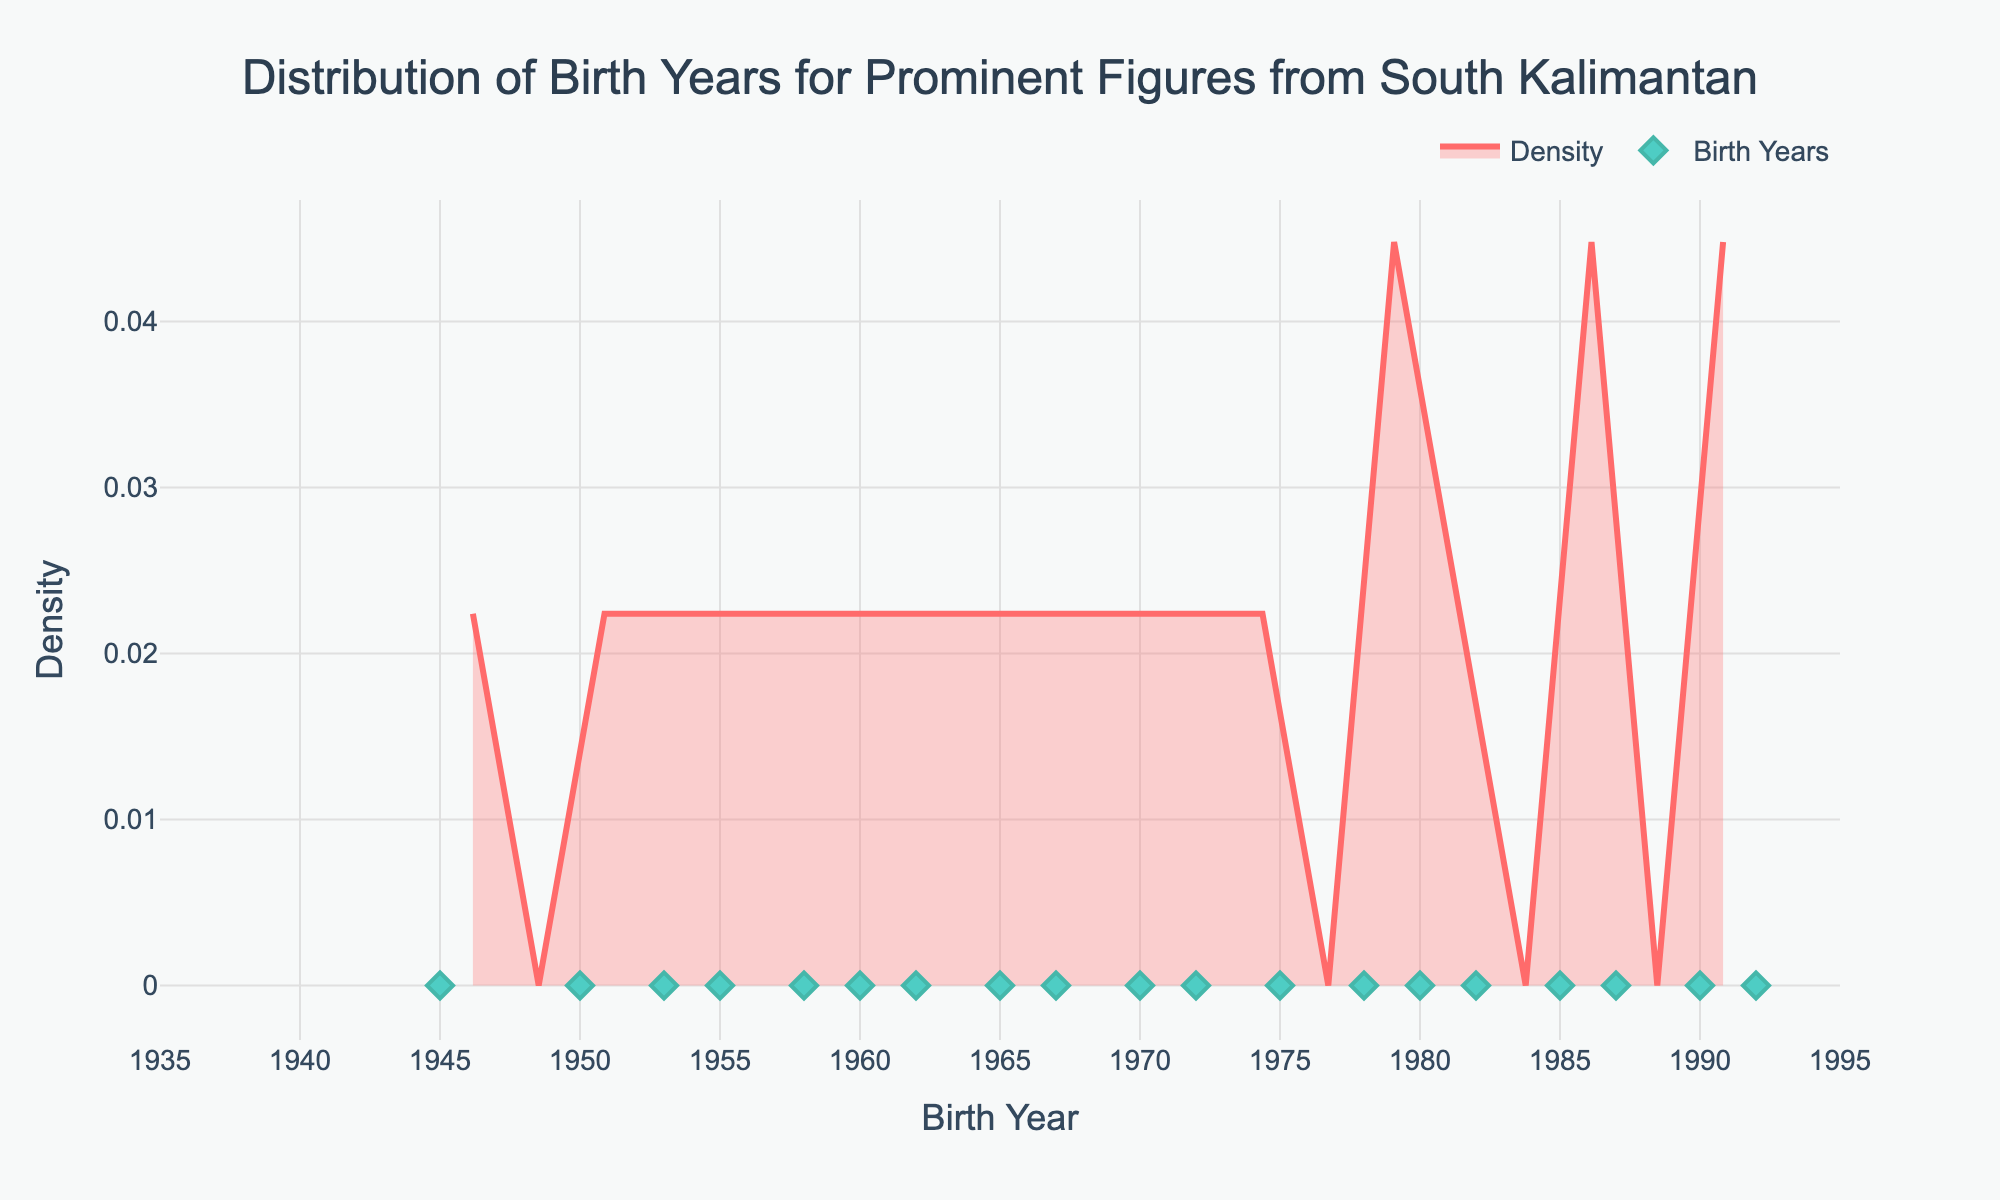What is the title of the plot? The title of the plot is displayed at the top of the figure. It provides a summary of the data being visualized. The title reads "Distribution of Birth Years for Prominent Figures from South Kalimantan".
Answer: Distribution of Birth Years for Prominent Figures from South Kalimantan What do the x-axis and y-axis represent? The x-axis represents the birth years ranging from 1935 to 1995, while the y-axis represents the density, indicating how the concentration of birth years is distributed.
Answer: Birth years and density What is the color of the density curve? The density curve is displayed in a specific color to distinguish it from other elements in the plot. The curve is colored in a shade of red (#FF6B6B) with a light red fill that has transparency.
Answer: Red How many prominent figures have birth years within the range of 1980 to 1990? To determine this, observe the scatter plot at the bottom of the density plot and count the number of data points that fall between 1980 and 1990. There are five data points within this range.
Answer: Five What is the range of birth years for the prominent figures? The range of birth years can be determined by the minimum and maximum values along the x-axis. The birth years range from 1940 to 1992.
Answer: From 1940 to 1992 During which decade is the density of birth years the highest? Look for the highest peak in the density curve, which represents the highest concentration of birth years. The peak occurs around the decade of 1950 to 1960.
Answer: 1950 - 1960 Which individual has the latest birth year, and what is that year? Examine the scatter plot at the bottom of the density plot to find the dot positioned furthest to the right. The individual with the latest birth year is Siti Fauziah, born in 1992.
Answer: Siti Fauziah, 1992 How does the density of birth years change from 1940 to 1960? To understand the change, look at the shape of the density curve between 1940 and 1960. The density increases steadily and peaks around the late 1950s.
Answer: Increases and peaks around the late 1950s Are there any birth years that have no prominent figures? Check for gaps in the scatter plot along the x-axis. A noticeable gap without any points indicates birth years with no prominent figures. There are no dots for the years 1941 through 1944.
Answer: Yes, 1941-1944 What is the approximate density value at the highest peak? Locate the highest point on the density curve and read the corresponding density value on the y-axis. The approximate density at the highest peak is around 0.1.
Answer: Around 0.1 